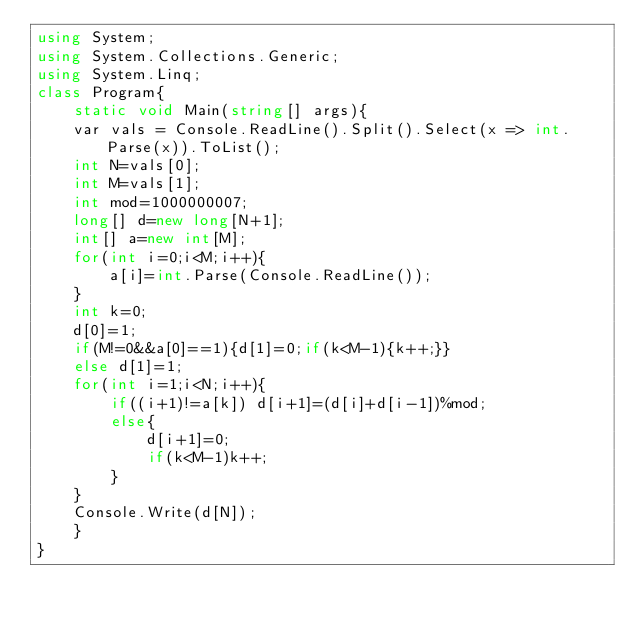Convert code to text. <code><loc_0><loc_0><loc_500><loc_500><_C#_>using System;
using System.Collections.Generic;
using System.Linq;
class Program{
    static void Main(string[] args){
    var vals = Console.ReadLine().Split().Select(x => int.Parse(x)).ToList();
    int N=vals[0];
    int M=vals[1];
    int mod=1000000007;
    long[] d=new long[N+1];
    int[] a=new int[M];
    for(int i=0;i<M;i++){
        a[i]=int.Parse(Console.ReadLine());
    }
    int k=0;
    d[0]=1;
    if(M!=0&&a[0]==1){d[1]=0;if(k<M-1){k++;}}
    else d[1]=1;
    for(int i=1;i<N;i++){
        if((i+1)!=a[k]) d[i+1]=(d[i]+d[i-1])%mod;
        else{
            d[i+1]=0;
            if(k<M-1)k++;
        }
    }
    Console.Write(d[N]);
    }
}
</code> 